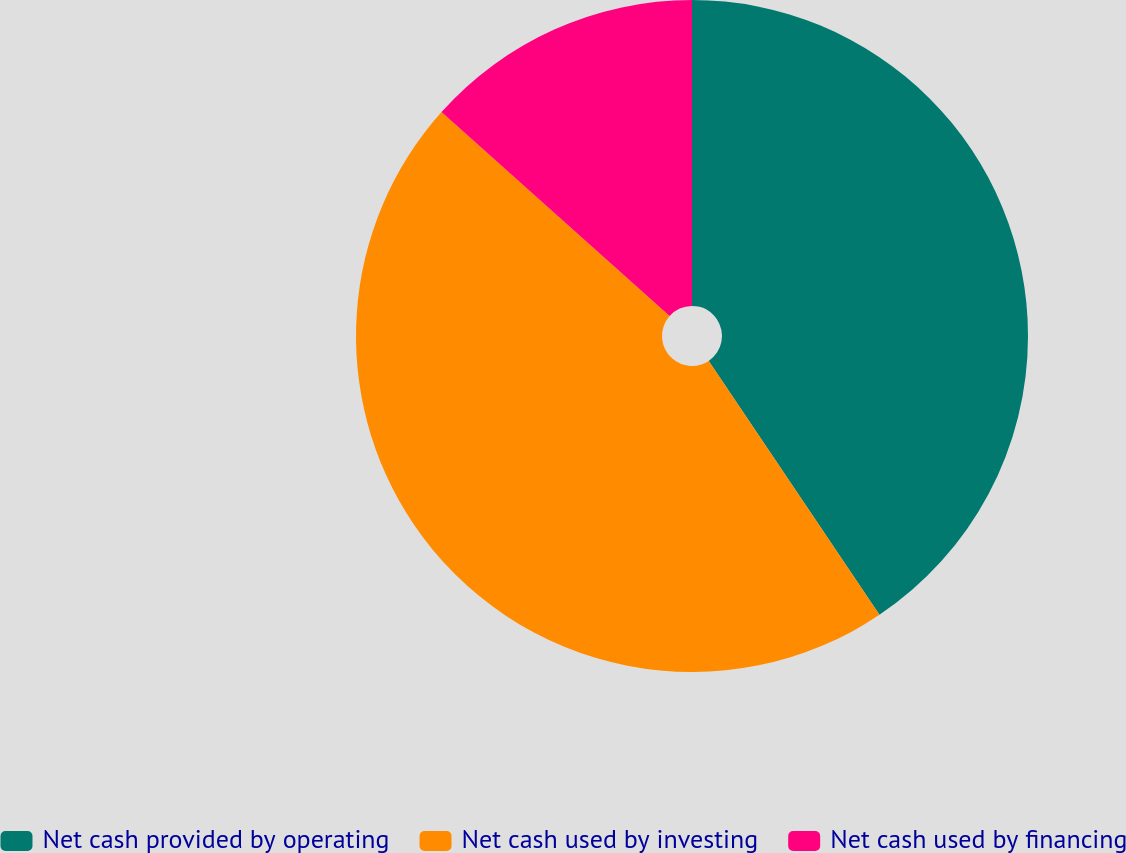<chart> <loc_0><loc_0><loc_500><loc_500><pie_chart><fcel>Net cash provided by operating<fcel>Net cash used by investing<fcel>Net cash used by financing<nl><fcel>40.58%<fcel>46.03%<fcel>13.39%<nl></chart> 